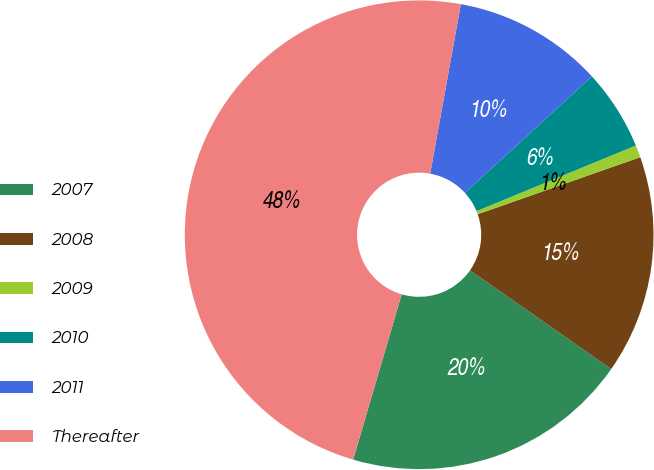Convert chart. <chart><loc_0><loc_0><loc_500><loc_500><pie_chart><fcel>2007<fcel>2008<fcel>2009<fcel>2010<fcel>2011<fcel>Thereafter<nl><fcel>19.83%<fcel>15.08%<fcel>0.85%<fcel>5.59%<fcel>10.34%<fcel>48.3%<nl></chart> 